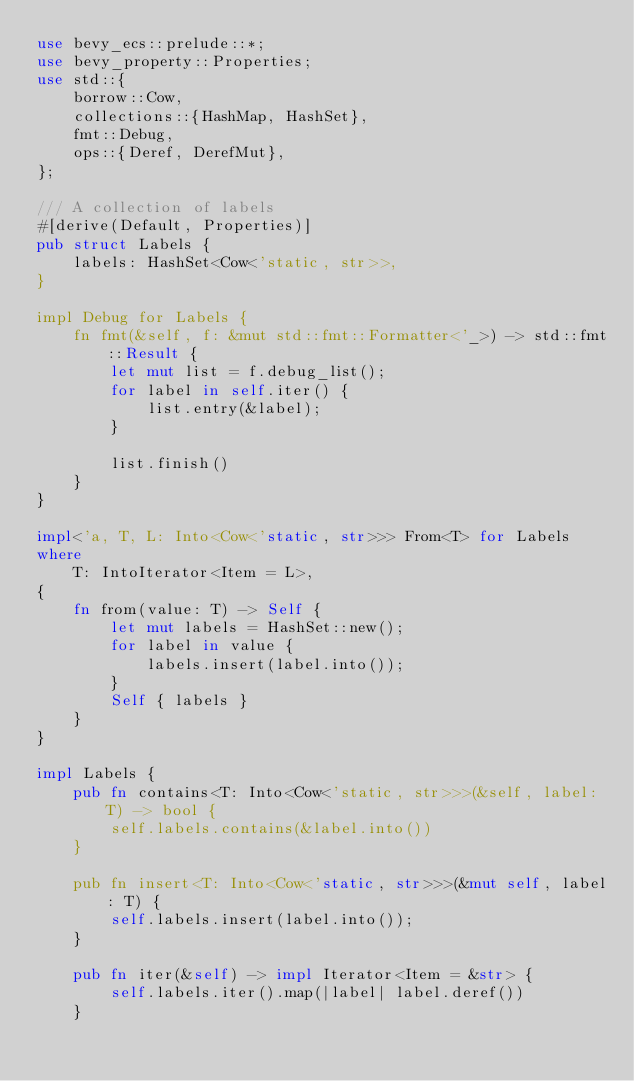<code> <loc_0><loc_0><loc_500><loc_500><_Rust_>use bevy_ecs::prelude::*;
use bevy_property::Properties;
use std::{
    borrow::Cow,
    collections::{HashMap, HashSet},
    fmt::Debug,
    ops::{Deref, DerefMut},
};

/// A collection of labels
#[derive(Default, Properties)]
pub struct Labels {
    labels: HashSet<Cow<'static, str>>,
}

impl Debug for Labels {
    fn fmt(&self, f: &mut std::fmt::Formatter<'_>) -> std::fmt::Result {
        let mut list = f.debug_list();
        for label in self.iter() {
            list.entry(&label);
        }

        list.finish()
    }
}

impl<'a, T, L: Into<Cow<'static, str>>> From<T> for Labels
where
    T: IntoIterator<Item = L>,
{
    fn from(value: T) -> Self {
        let mut labels = HashSet::new();
        for label in value {
            labels.insert(label.into());
        }
        Self { labels }
    }
}

impl Labels {
    pub fn contains<T: Into<Cow<'static, str>>>(&self, label: T) -> bool {
        self.labels.contains(&label.into())
    }

    pub fn insert<T: Into<Cow<'static, str>>>(&mut self, label: T) {
        self.labels.insert(label.into());
    }

    pub fn iter(&self) -> impl Iterator<Item = &str> {
        self.labels.iter().map(|label| label.deref())
    }</code> 